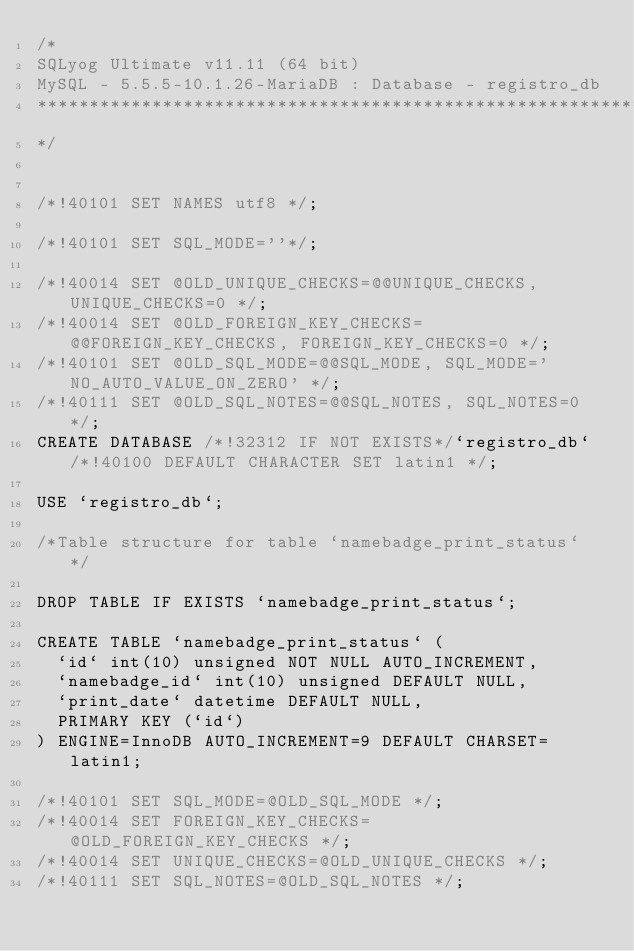<code> <loc_0><loc_0><loc_500><loc_500><_SQL_>/*
SQLyog Ultimate v11.11 (64 bit)
MySQL - 5.5.5-10.1.26-MariaDB : Database - registro_db
*********************************************************************
*/

/*!40101 SET NAMES utf8 */;

/*!40101 SET SQL_MODE=''*/;

/*!40014 SET @OLD_UNIQUE_CHECKS=@@UNIQUE_CHECKS, UNIQUE_CHECKS=0 */;
/*!40014 SET @OLD_FOREIGN_KEY_CHECKS=@@FOREIGN_KEY_CHECKS, FOREIGN_KEY_CHECKS=0 */;
/*!40101 SET @OLD_SQL_MODE=@@SQL_MODE, SQL_MODE='NO_AUTO_VALUE_ON_ZERO' */;
/*!40111 SET @OLD_SQL_NOTES=@@SQL_NOTES, SQL_NOTES=0 */;
CREATE DATABASE /*!32312 IF NOT EXISTS*/`registro_db` /*!40100 DEFAULT CHARACTER SET latin1 */;

USE `registro_db`;

/*Table structure for table `namebadge_print_status` */

DROP TABLE IF EXISTS `namebadge_print_status`;

CREATE TABLE `namebadge_print_status` (
  `id` int(10) unsigned NOT NULL AUTO_INCREMENT,
  `namebadge_id` int(10) unsigned DEFAULT NULL,
  `print_date` datetime DEFAULT NULL,
  PRIMARY KEY (`id`)
) ENGINE=InnoDB AUTO_INCREMENT=9 DEFAULT CHARSET=latin1;

/*!40101 SET SQL_MODE=@OLD_SQL_MODE */;
/*!40014 SET FOREIGN_KEY_CHECKS=@OLD_FOREIGN_KEY_CHECKS */;
/*!40014 SET UNIQUE_CHECKS=@OLD_UNIQUE_CHECKS */;
/*!40111 SET SQL_NOTES=@OLD_SQL_NOTES */;
</code> 